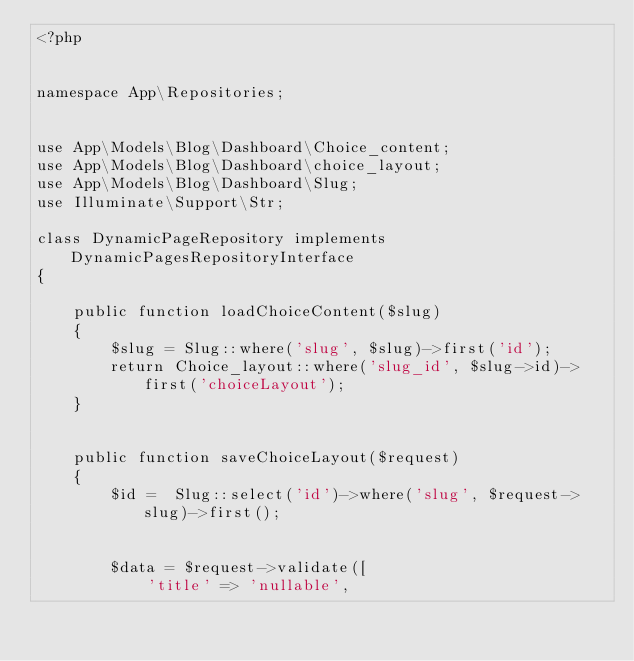Convert code to text. <code><loc_0><loc_0><loc_500><loc_500><_PHP_><?php


namespace App\Repositories;


use App\Models\Blog\Dashboard\Choice_content;
use App\Models\Blog\Dashboard\choice_layout;
use App\Models\Blog\Dashboard\Slug;
use Illuminate\Support\Str;

class DynamicPageRepository implements DynamicPagesRepositoryInterface
{

    public function loadChoiceContent($slug)
    {
        $slug = Slug::where('slug', $slug)->first('id');
        return Choice_layout::where('slug_id', $slug->id)->first('choiceLayout');
    }


    public function saveChoiceLayout($request)
    {
        $id =  Slug::select('id')->where('slug', $request->slug)->first();


        $data = $request->validate([
            'title' => 'nullable',</code> 